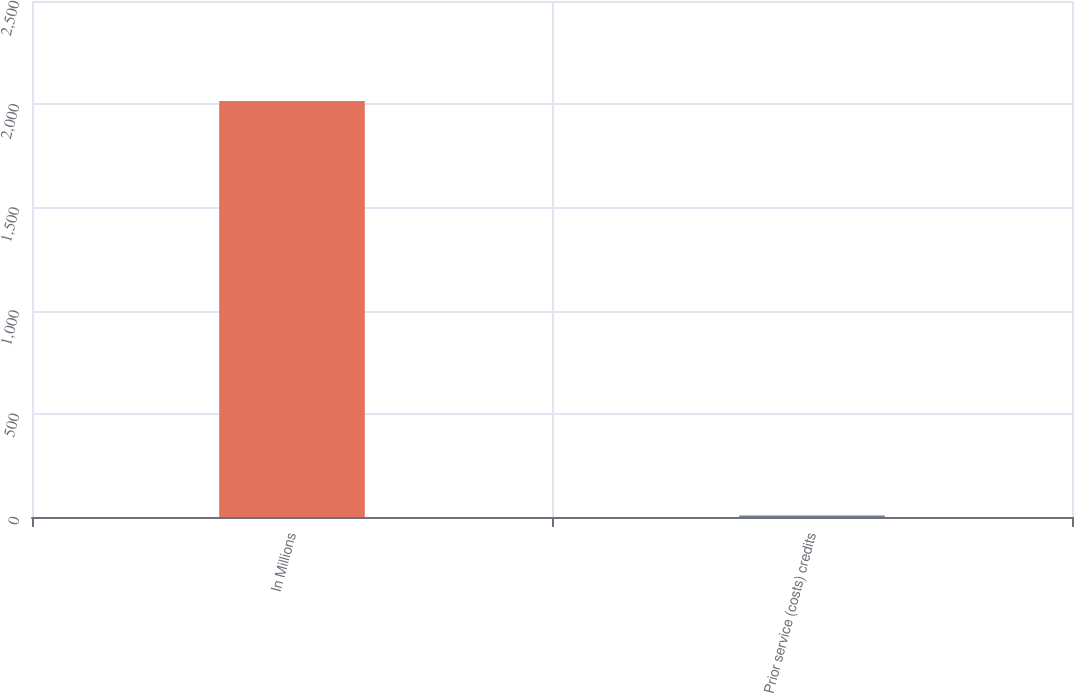<chart> <loc_0><loc_0><loc_500><loc_500><bar_chart><fcel>In Millions<fcel>Prior service (costs) credits<nl><fcel>2016<fcel>6.8<nl></chart> 